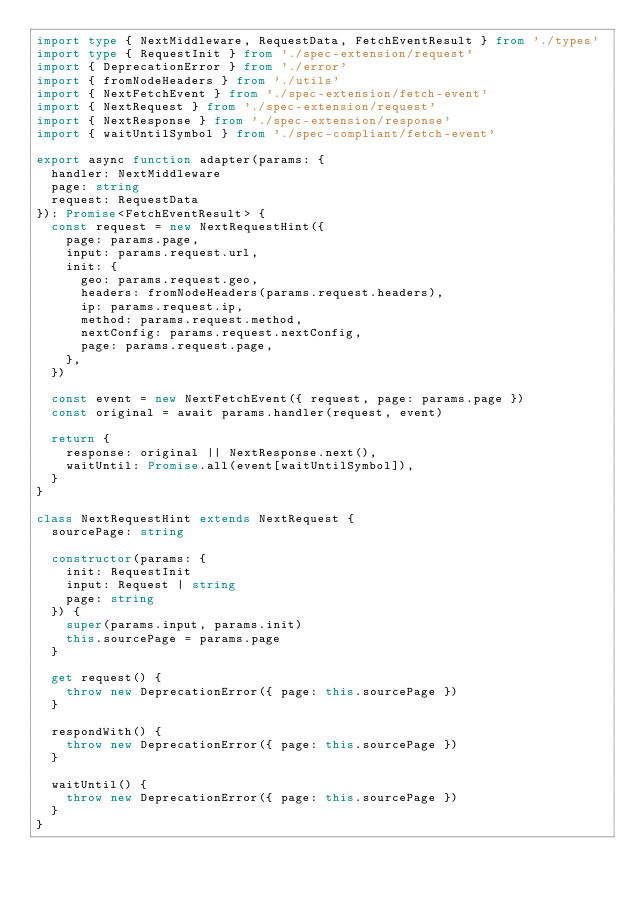Convert code to text. <code><loc_0><loc_0><loc_500><loc_500><_TypeScript_>import type { NextMiddleware, RequestData, FetchEventResult } from './types'
import type { RequestInit } from './spec-extension/request'
import { DeprecationError } from './error'
import { fromNodeHeaders } from './utils'
import { NextFetchEvent } from './spec-extension/fetch-event'
import { NextRequest } from './spec-extension/request'
import { NextResponse } from './spec-extension/response'
import { waitUntilSymbol } from './spec-compliant/fetch-event'

export async function adapter(params: {
  handler: NextMiddleware
  page: string
  request: RequestData
}): Promise<FetchEventResult> {
  const request = new NextRequestHint({
    page: params.page,
    input: params.request.url,
    init: {
      geo: params.request.geo,
      headers: fromNodeHeaders(params.request.headers),
      ip: params.request.ip,
      method: params.request.method,
      nextConfig: params.request.nextConfig,
      page: params.request.page,
    },
  })

  const event = new NextFetchEvent({ request, page: params.page })
  const original = await params.handler(request, event)

  return {
    response: original || NextResponse.next(),
    waitUntil: Promise.all(event[waitUntilSymbol]),
  }
}

class NextRequestHint extends NextRequest {
  sourcePage: string

  constructor(params: {
    init: RequestInit
    input: Request | string
    page: string
  }) {
    super(params.input, params.init)
    this.sourcePage = params.page
  }

  get request() {
    throw new DeprecationError({ page: this.sourcePage })
  }

  respondWith() {
    throw new DeprecationError({ page: this.sourcePage })
  }

  waitUntil() {
    throw new DeprecationError({ page: this.sourcePage })
  }
}
</code> 